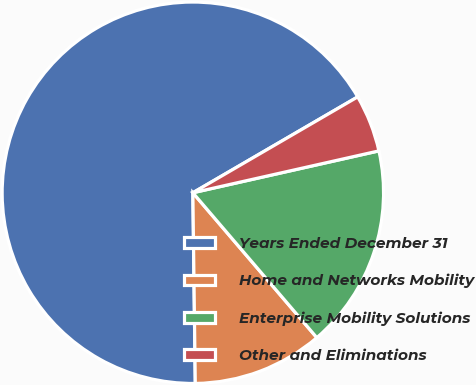Convert chart to OTSL. <chart><loc_0><loc_0><loc_500><loc_500><pie_chart><fcel>Years Ended December 31<fcel>Home and Networks Mobility<fcel>Enterprise Mobility Solutions<fcel>Other and Eliminations<nl><fcel>66.82%<fcel>11.06%<fcel>17.26%<fcel>4.86%<nl></chart> 